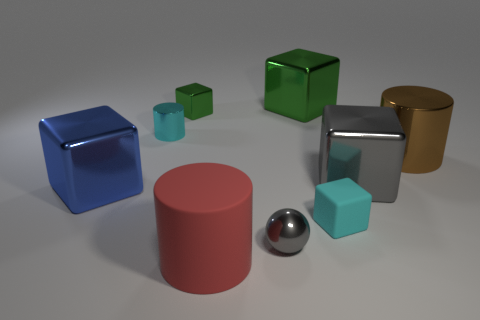How many objects are either small green cubes or blue metal cubes?
Offer a terse response. 2. Are the big blue cube and the cyan thing in front of the blue metal object made of the same material?
Give a very brief answer. No. There is a rubber thing that is to the left of the tiny rubber thing; how big is it?
Keep it short and to the point. Large. Are there fewer green things than large green blocks?
Provide a succinct answer. No. Is there a large rubber block that has the same color as the large rubber cylinder?
Your answer should be very brief. No. There is a metal object that is on the left side of the big green metallic cube and behind the small cylinder; what is its shape?
Offer a terse response. Cube. There is a big object on the left side of the tiny cube behind the brown metal cylinder; what is its shape?
Provide a short and direct response. Cube. Is the shape of the small cyan matte thing the same as the large green shiny thing?
Keep it short and to the point. Yes. What is the material of the block that is the same color as the small metallic ball?
Your answer should be compact. Metal. Do the small rubber block and the small shiny sphere have the same color?
Make the answer very short. No. 